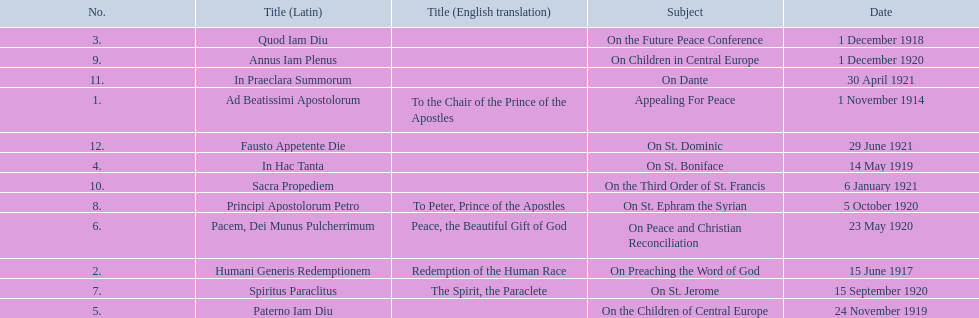What are all the subjects? Appealing For Peace, On Preaching the Word of God, On the Future Peace Conference, On St. Boniface, On the Children of Central Europe, On Peace and Christian Reconciliation, On St. Jerome, On St. Ephram the Syrian, On Children in Central Europe, On the Third Order of St. Francis, On Dante, On St. Dominic. Which occurred in 1920? On Peace and Christian Reconciliation, On St. Jerome, On St. Ephram the Syrian, On Children in Central Europe. Which occurred in may of that year? On Peace and Christian Reconciliation. 